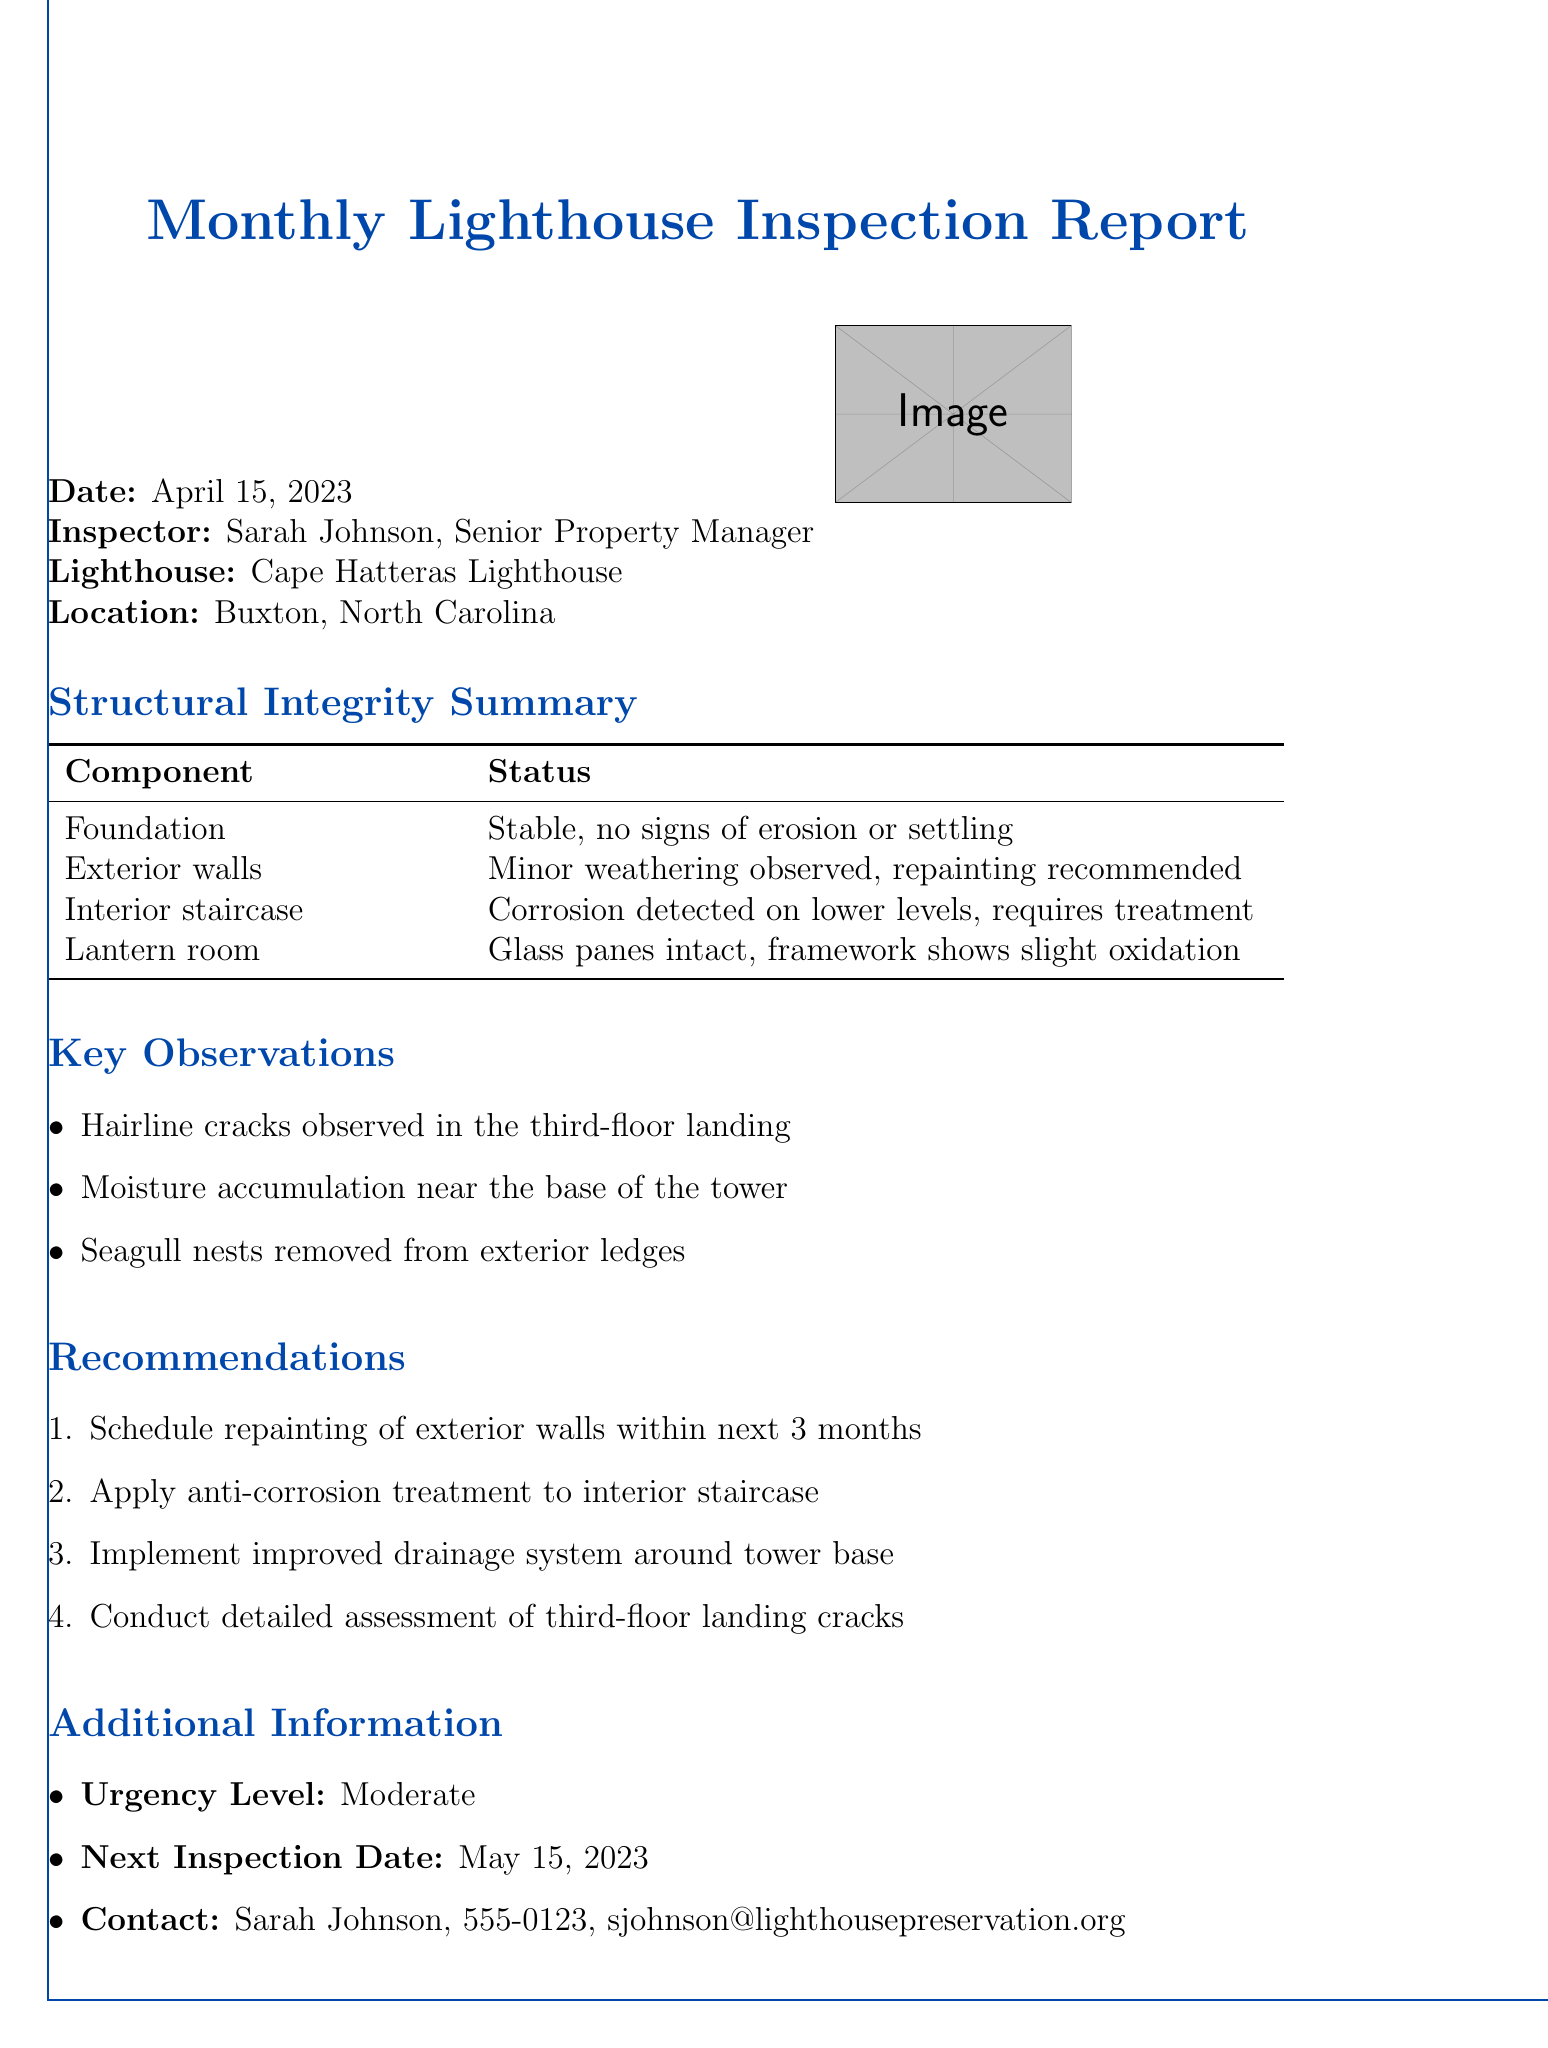What is the date of the inspection? The date of the inspection is explicitly mentioned in the document.
Answer: April 15, 2023 Who is the inspector? The name of the inspector is listed in the report.
Answer: Sarah Johnson What is the status of the foundation? The status of the foundation is provided in the structural integrity summary.
Answer: Stable, no signs of erosion or settling What is the recommended action for the interior staircase? The recommendation related to the interior staircase is found in the recommendations section.
Answer: Apply anti-corrosion treatment How many key observations are listed? The number of key observations can be counted from the document.
Answer: Three What observation is noted for the third-floor landing? This detail is provided in the key observations section.
Answer: Hairline cracks observed What is the urgency level of the inspection report? The urgency level is stated within the additional information section.
Answer: Moderate When is the next inspection date? The next inspection date is clearly specified in the additional information.
Answer: May 15, 2023 What type of treatment is suggested for the exterior walls? This suggestion is found in the recommendations part concerning the exterior walls.
Answer: Repainting 